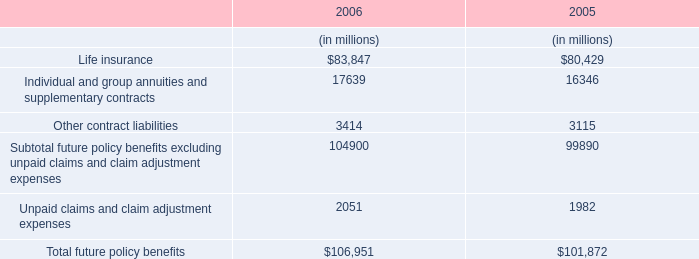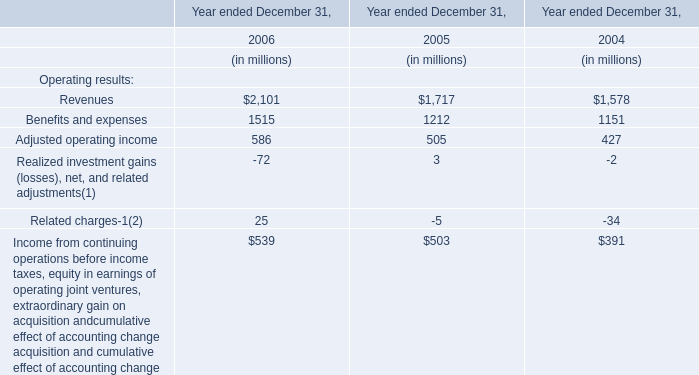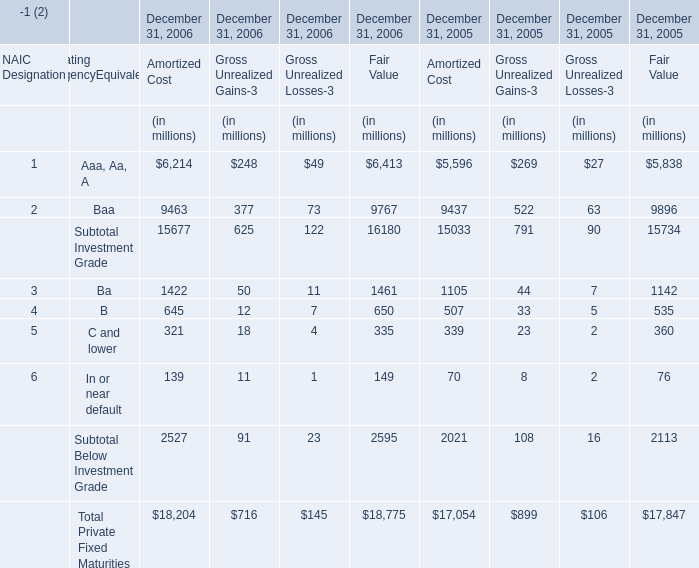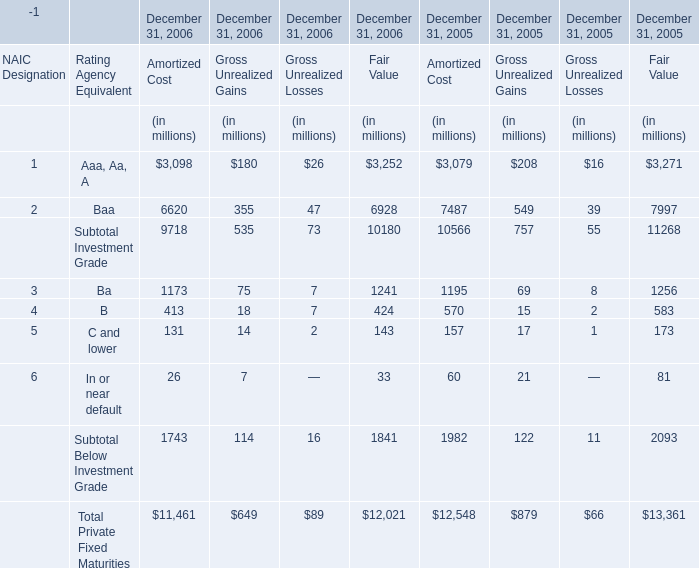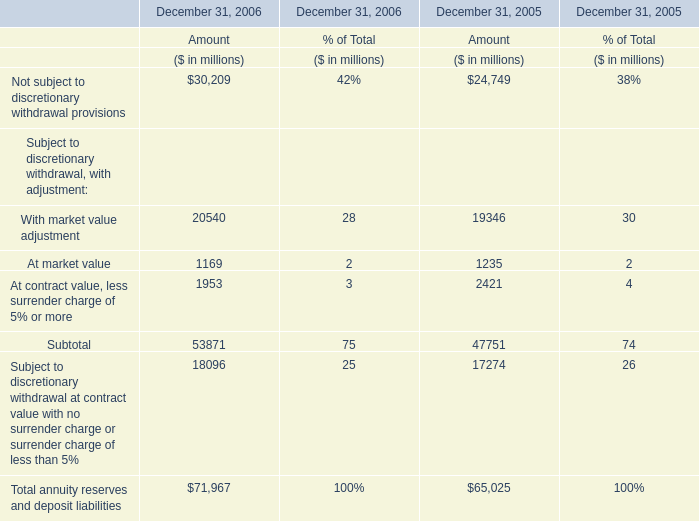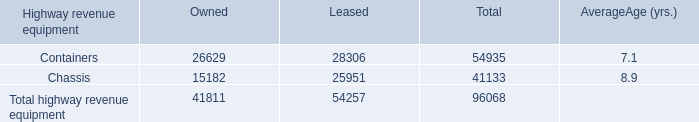How many kinds of Amortized Cost are greater than 0 in 2006? 
Answer: 9. 